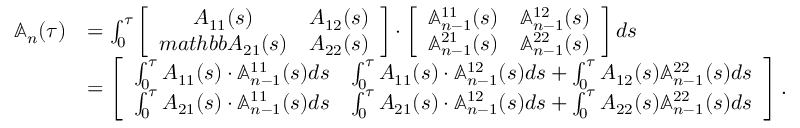Convert formula to latex. <formula><loc_0><loc_0><loc_500><loc_500>\begin{array} { r l } { \mathbb { A } _ { n } ( \tau ) } & { = \int _ { 0 } ^ { \tau } \left [ \begin{array} { c c } { A _ { 1 1 } ( s ) } & { A _ { 1 2 } ( s ) } \\ { m a t h b b { A } _ { 2 1 } ( s ) } & { A _ { 2 2 } ( s ) } \end{array} \right ] \cdot \left [ \begin{array} { c c } { \mathbb { A } _ { n - 1 } ^ { 1 1 } ( s ) } & { \mathbb { A } _ { n - 1 } ^ { 1 2 } ( s ) } \\ { \mathbb { A } _ { n - 1 } ^ { 2 1 } ( s ) } & { \mathbb { A } _ { n - 1 } ^ { 2 2 } ( s ) } \end{array} \right ] d s } \\ & { = \left [ \begin{array} { c c } { \int _ { 0 } ^ { \tau } A _ { 1 1 } ( s ) \cdot \mathbb { A } _ { n - 1 } ^ { 1 1 } ( s ) d s } & { \int _ { 0 } ^ { \tau } A _ { 1 1 } ( s ) \cdot \mathbb { A } _ { n - 1 } ^ { 1 2 } ( s ) d s + \int _ { 0 } ^ { \tau } A _ { 1 2 } ( s ) \mathbb { A } _ { n - 1 } ^ { 2 2 } ( s ) d s } \\ { \int _ { 0 } ^ { \tau } A _ { 2 1 } ( s ) \cdot \mathbb { A } _ { n - 1 } ^ { 1 1 } ( s ) d s } & { \int _ { 0 } ^ { \tau } A _ { 2 1 } ( s ) \cdot \mathbb { A } _ { n - 1 } ^ { 1 2 } ( s ) d s + \int _ { 0 } ^ { \tau } A _ { 2 2 } ( s ) \mathbb { A } _ { n - 1 } ^ { 2 2 } ( s ) d s } \end{array} \right ] . } \end{array}</formula> 